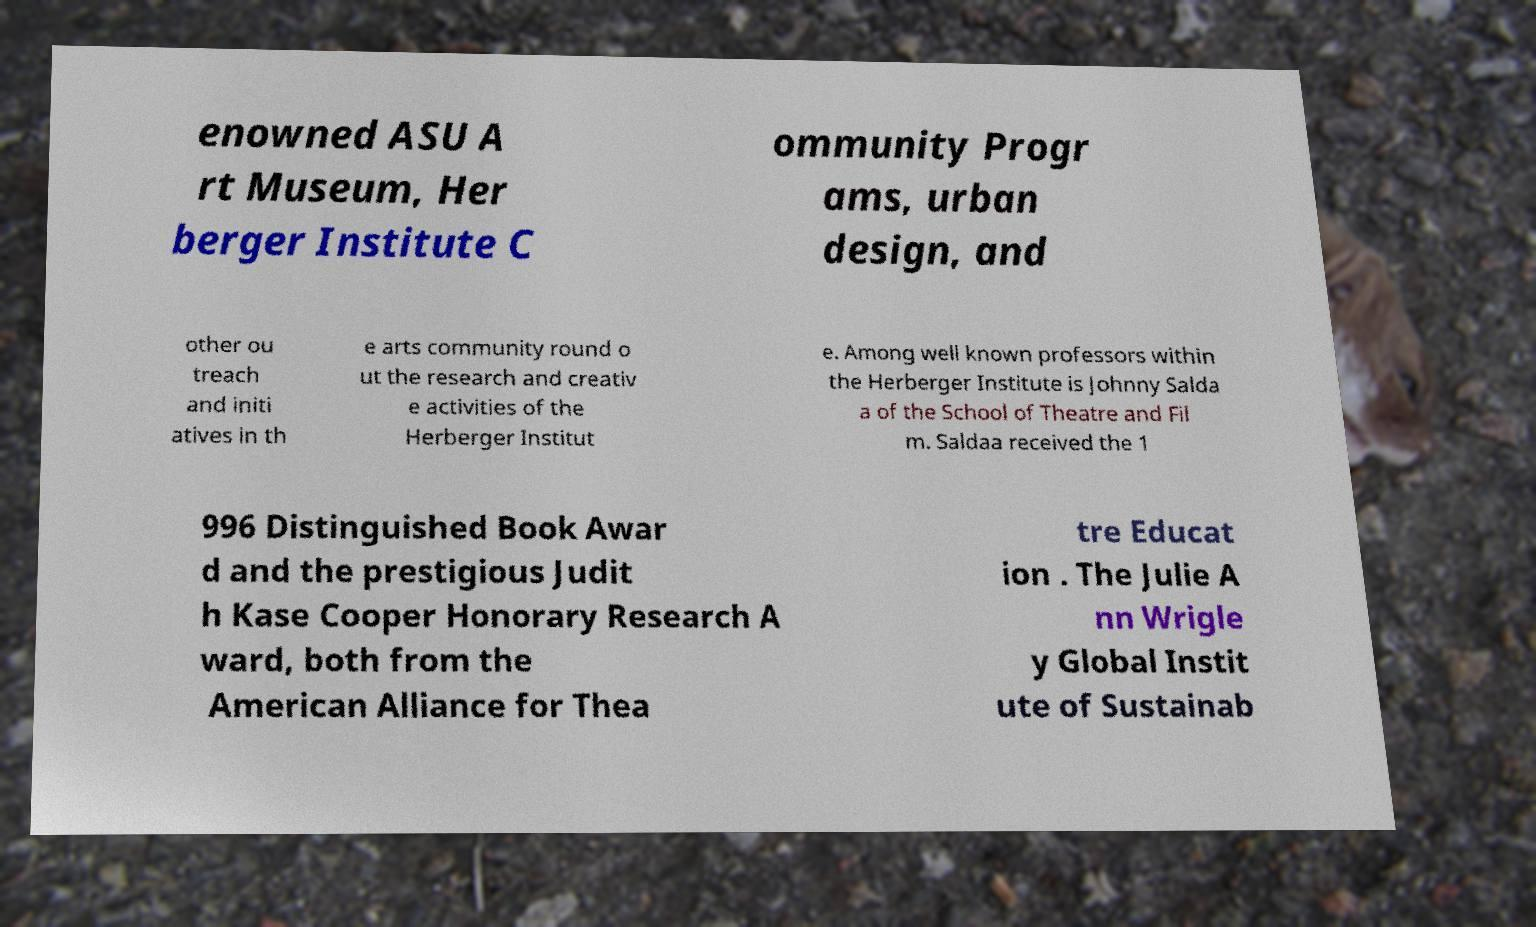Could you extract and type out the text from this image? enowned ASU A rt Museum, Her berger Institute C ommunity Progr ams, urban design, and other ou treach and initi atives in th e arts community round o ut the research and creativ e activities of the Herberger Institut e. Among well known professors within the Herberger Institute is Johnny Salda a of the School of Theatre and Fil m. Saldaa received the 1 996 Distinguished Book Awar d and the prestigious Judit h Kase Cooper Honorary Research A ward, both from the American Alliance for Thea tre Educat ion . The Julie A nn Wrigle y Global Instit ute of Sustainab 